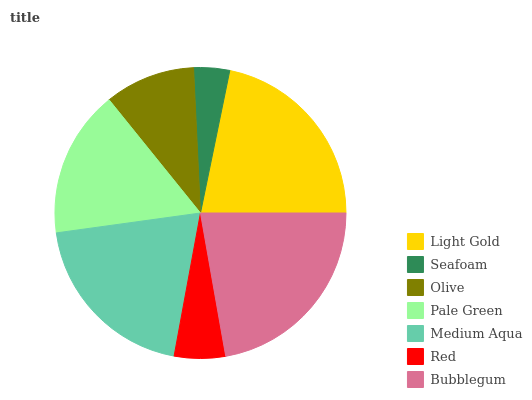Is Seafoam the minimum?
Answer yes or no. Yes. Is Bubblegum the maximum?
Answer yes or no. Yes. Is Olive the minimum?
Answer yes or no. No. Is Olive the maximum?
Answer yes or no. No. Is Olive greater than Seafoam?
Answer yes or no. Yes. Is Seafoam less than Olive?
Answer yes or no. Yes. Is Seafoam greater than Olive?
Answer yes or no. No. Is Olive less than Seafoam?
Answer yes or no. No. Is Pale Green the high median?
Answer yes or no. Yes. Is Pale Green the low median?
Answer yes or no. Yes. Is Olive the high median?
Answer yes or no. No. Is Light Gold the low median?
Answer yes or no. No. 